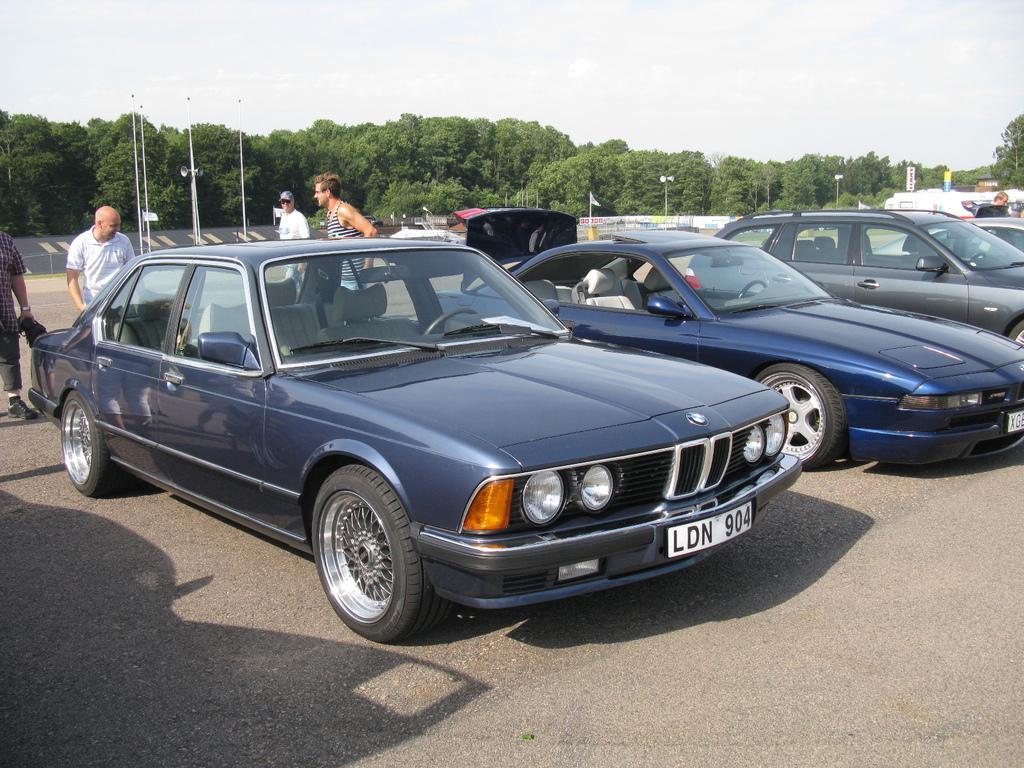Describe this image in one or two sentences. In this image there are vehicles parked on the path, there are group of people standing, there are poles, lights , megaphones, flag , trees, and in the background there is sky. 